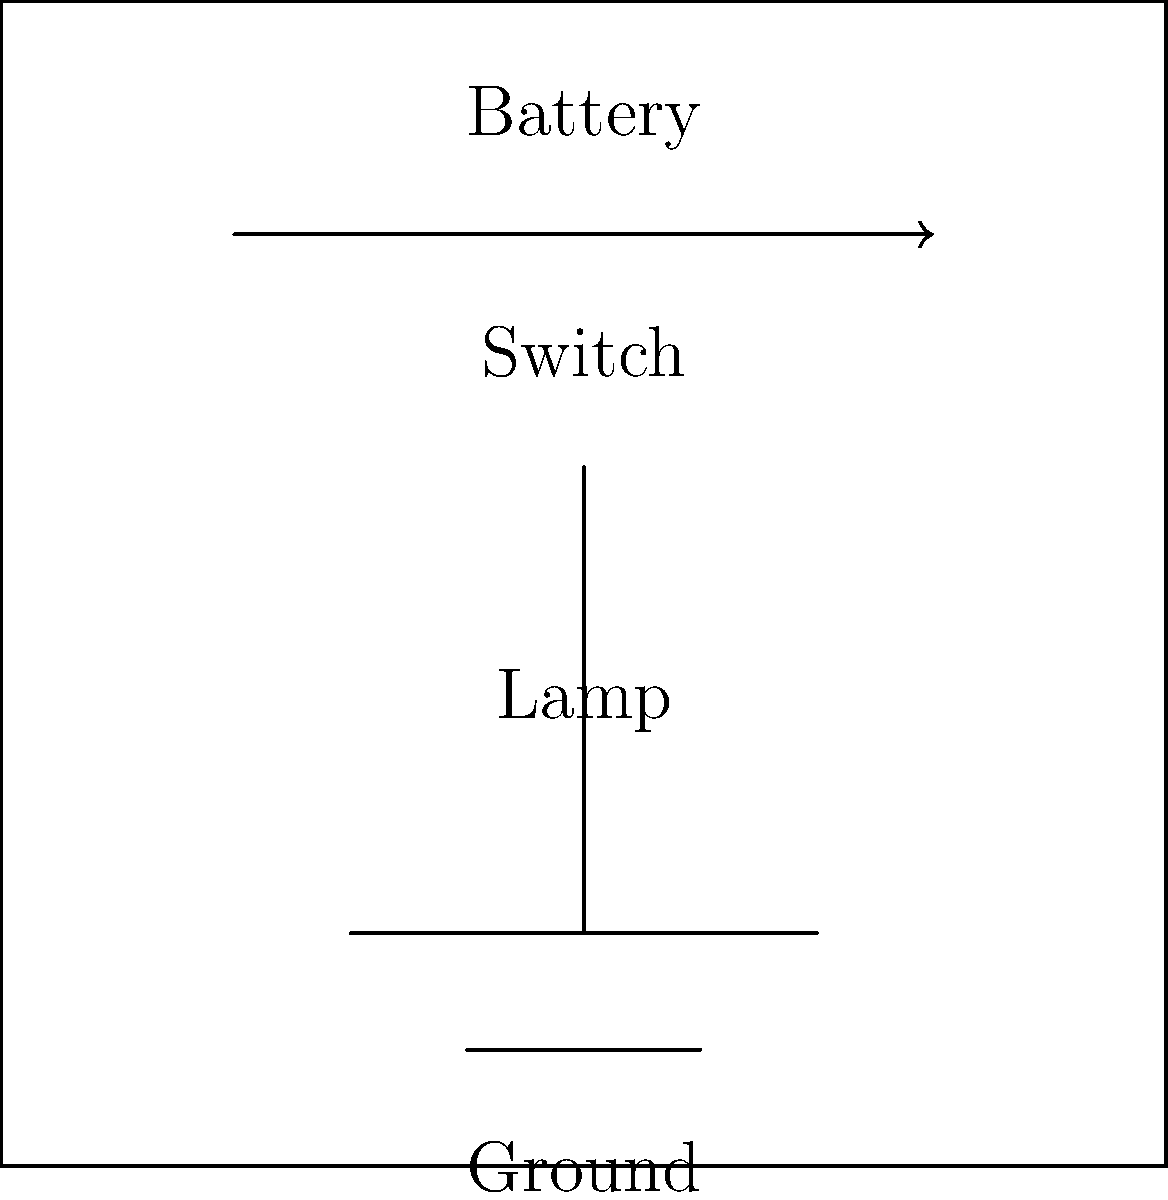In the simplified circuit diagram of a train's lighting system shown above, what would happen to the lamp if the switch is closed? To understand what happens when the switch is closed, let's follow these steps:

1. The circuit consists of a battery (power source), a switch, a lamp, and a ground connection.

2. When the switch is open (as shown in the diagram), there is no complete path for the current to flow from the battery through the lamp and back to the battery.

3. When the switch is closed:
   a. It creates a complete circuit path.
   b. Current can now flow from the positive terminal of the battery.
   c. The current passes through the closed switch.
   d. It then flows through the lamp.
   e. Finally, it returns to the negative terminal of the battery via the ground connection.

4. When current flows through the lamp:
   a. Electrical energy is converted into light and heat energy.
   b. This causes the lamp to illuminate.

5. The brightness of the lamp depends on factors such as:
   a. The voltage of the battery.
   b. The resistance of the lamp.
   c. Any other resistances in the circuit.

Therefore, when the switch is closed, the lamp will light up as it becomes part of a complete circuit, allowing current to flow through it.
Answer: The lamp will light up. 